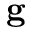Convert formula to latex. <formula><loc_0><loc_0><loc_500><loc_500>g</formula> 